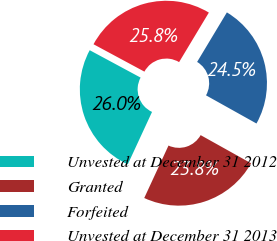<chart> <loc_0><loc_0><loc_500><loc_500><pie_chart><fcel>Unvested at December 31 2012<fcel>Granted<fcel>Forfeited<fcel>Unvested at December 31 2013<nl><fcel>25.96%<fcel>23.79%<fcel>24.49%<fcel>25.75%<nl></chart> 